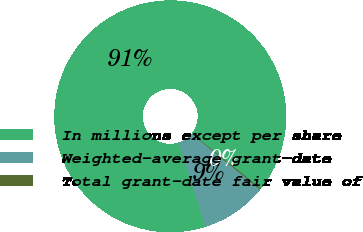Convert chart to OTSL. <chart><loc_0><loc_0><loc_500><loc_500><pie_chart><fcel>In millions except per share<fcel>Weighted-average grant-date<fcel>Total grant-date fair value of<nl><fcel>90.64%<fcel>9.21%<fcel>0.16%<nl></chart> 